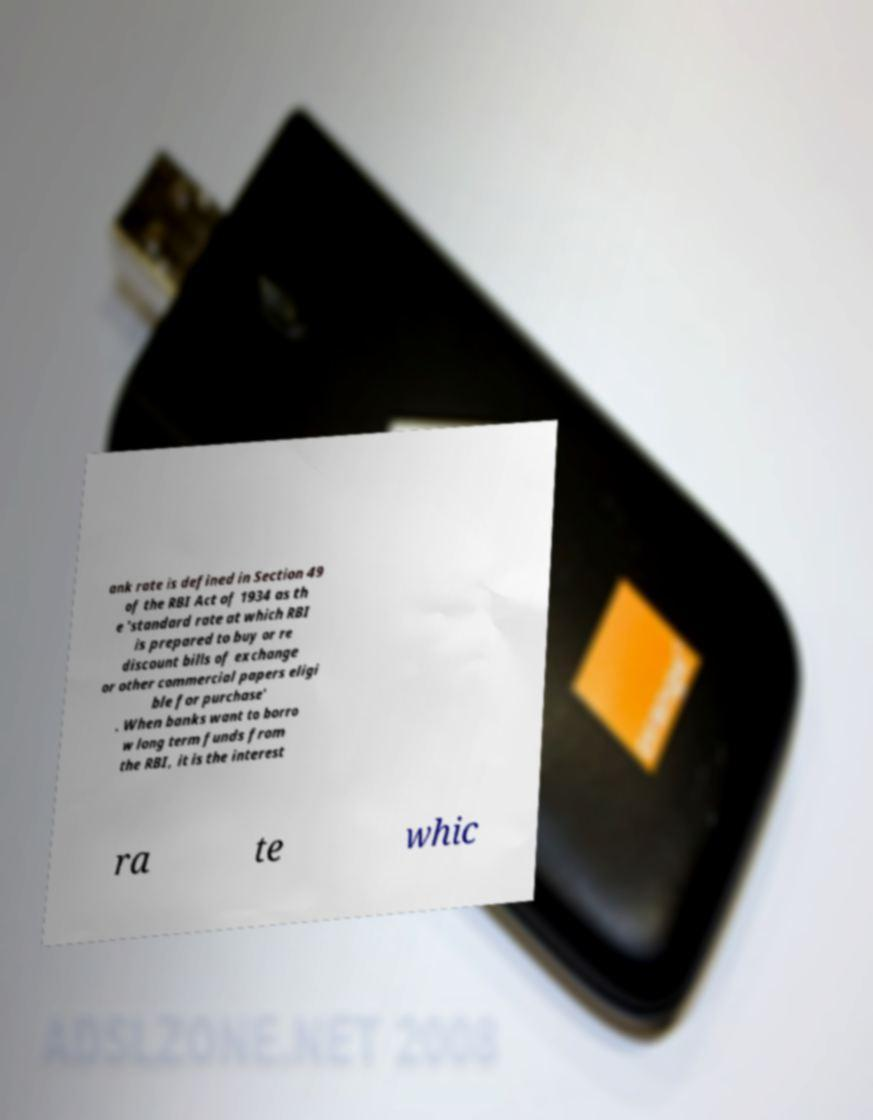Can you read and provide the text displayed in the image?This photo seems to have some interesting text. Can you extract and type it out for me? ank rate is defined in Section 49 of the RBI Act of 1934 as th e 'standard rate at which RBI is prepared to buy or re discount bills of exchange or other commercial papers eligi ble for purchase' . When banks want to borro w long term funds from the RBI, it is the interest ra te whic 